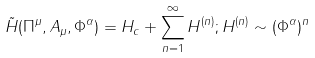<formula> <loc_0><loc_0><loc_500><loc_500>\tilde { H } ( \Pi ^ { \mu } , A _ { \mu } , \Phi ^ { \alpha } ) = H _ { c } + \sum _ { n = 1 } ^ { \infty } H ^ { ( n ) } ; H ^ { ( n ) } \sim ( \Phi ^ { \alpha } ) ^ { n }</formula> 